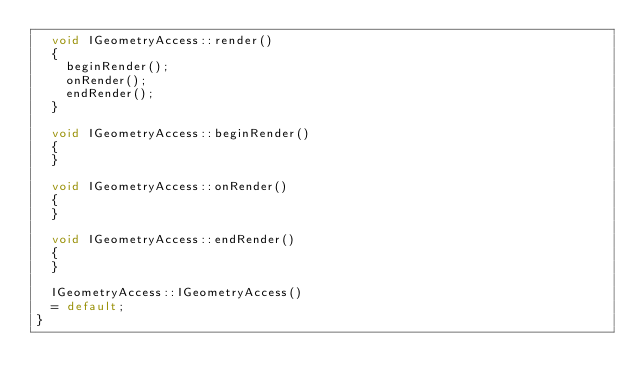<code> <loc_0><loc_0><loc_500><loc_500><_C++_>	void IGeometryAccess::render()
	{
		beginRender();
		onRender();
		endRender();
	}

	void IGeometryAccess::beginRender()
	{
	}

	void IGeometryAccess::onRender()
	{
	}

	void IGeometryAccess::endRender()
	{
	}

	IGeometryAccess::IGeometryAccess()
	= default;
}
</code> 